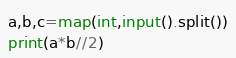Convert code to text. <code><loc_0><loc_0><loc_500><loc_500><_Python_>a,b,c=map(int,input().split())
print(a*b//2)
</code> 